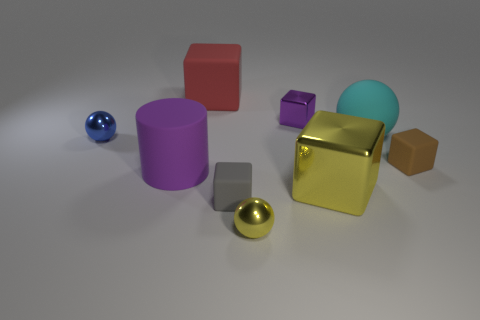Is there a gray thing that has the same material as the yellow block?
Provide a short and direct response. No. Are there more rubber balls that are left of the tiny yellow metallic ball than large red blocks on the right side of the large metallic cube?
Your response must be concise. No. Do the cyan object and the gray rubber block have the same size?
Offer a very short reply. No. There is a shiny block that is behind the tiny ball on the left side of the yellow metal ball; what color is it?
Make the answer very short. Purple. What is the color of the large metallic object?
Your answer should be compact. Yellow. Is there a tiny cube that has the same color as the rubber cylinder?
Offer a terse response. Yes. Does the metal object in front of the large shiny cube have the same color as the large shiny thing?
Your answer should be very brief. Yes. How many things are tiny objects that are right of the big cyan object or gray rubber cubes?
Provide a short and direct response. 2. There is a small purple cube; are there any objects in front of it?
Your answer should be compact. Yes. There is a large cylinder that is the same color as the tiny shiny cube; what material is it?
Ensure brevity in your answer.  Rubber. 